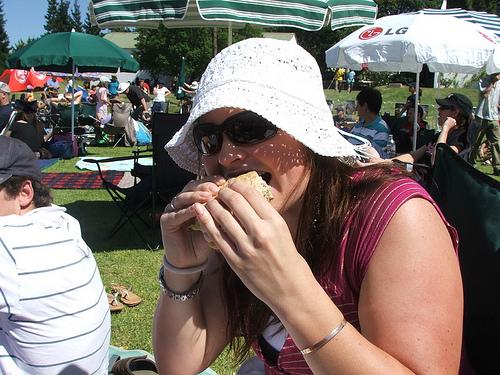Is this woman's woven hat efficiently protecting her face form the sun?
Keep it brief. Yes. Is the woman in the foreground wearing a ring?
Write a very short answer. Yes. What color is her hat?
Be succinct. White. 